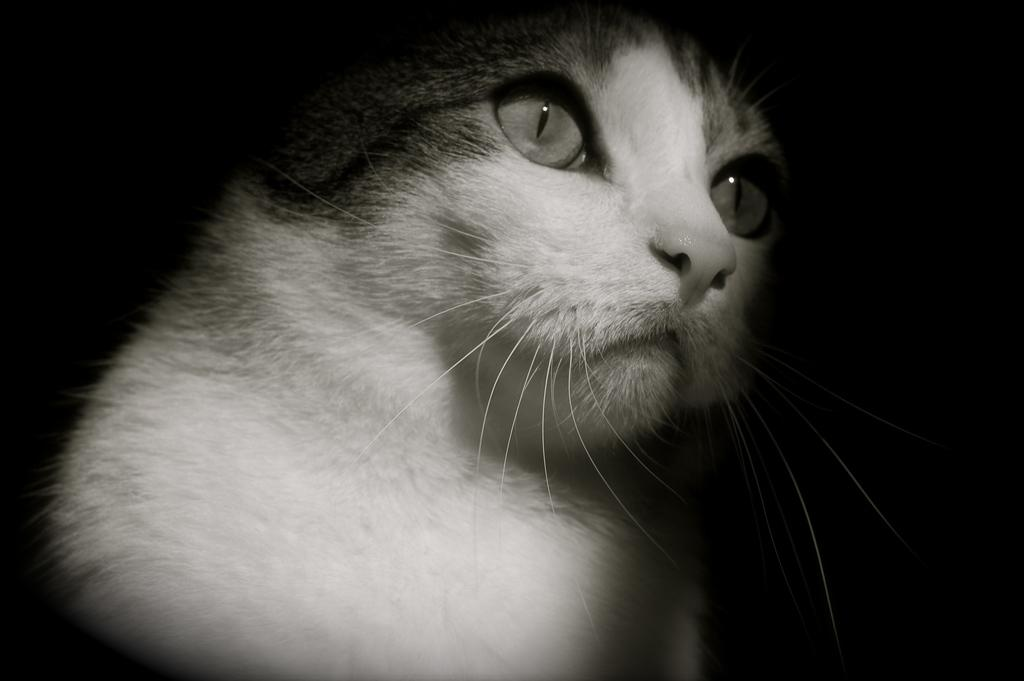What is the color scheme of the image? The image is black and white. What is the main subject of the image? There is a cat in the middle of the image. What way does the minister learn about the cat's behavior in the image? There is no minister or learning about the cat's behavior in the image, as it only features a black and white cat. 